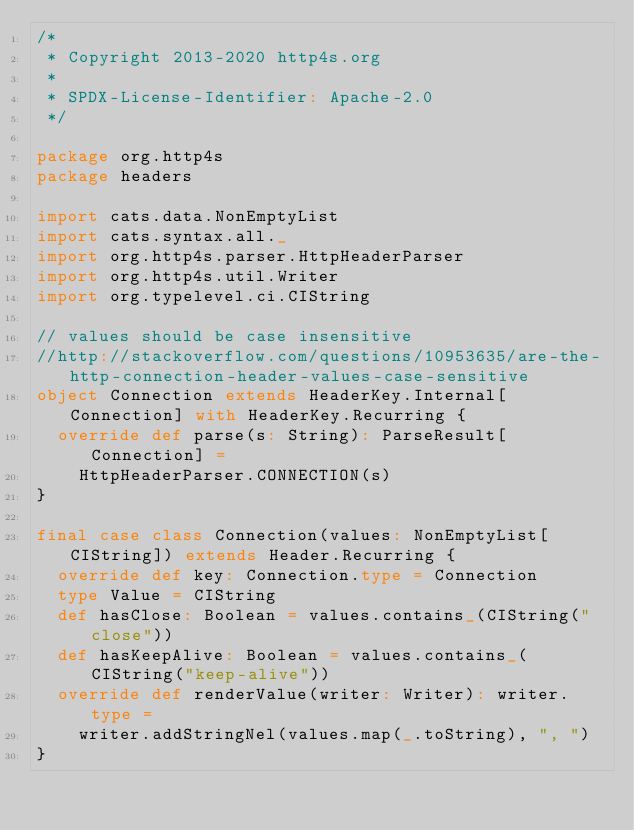Convert code to text. <code><loc_0><loc_0><loc_500><loc_500><_Scala_>/*
 * Copyright 2013-2020 http4s.org
 *
 * SPDX-License-Identifier: Apache-2.0
 */

package org.http4s
package headers

import cats.data.NonEmptyList
import cats.syntax.all._
import org.http4s.parser.HttpHeaderParser
import org.http4s.util.Writer
import org.typelevel.ci.CIString

// values should be case insensitive
//http://stackoverflow.com/questions/10953635/are-the-http-connection-header-values-case-sensitive
object Connection extends HeaderKey.Internal[Connection] with HeaderKey.Recurring {
  override def parse(s: String): ParseResult[Connection] =
    HttpHeaderParser.CONNECTION(s)
}

final case class Connection(values: NonEmptyList[CIString]) extends Header.Recurring {
  override def key: Connection.type = Connection
  type Value = CIString
  def hasClose: Boolean = values.contains_(CIString("close"))
  def hasKeepAlive: Boolean = values.contains_(CIString("keep-alive"))
  override def renderValue(writer: Writer): writer.type =
    writer.addStringNel(values.map(_.toString), ", ")
}
</code> 